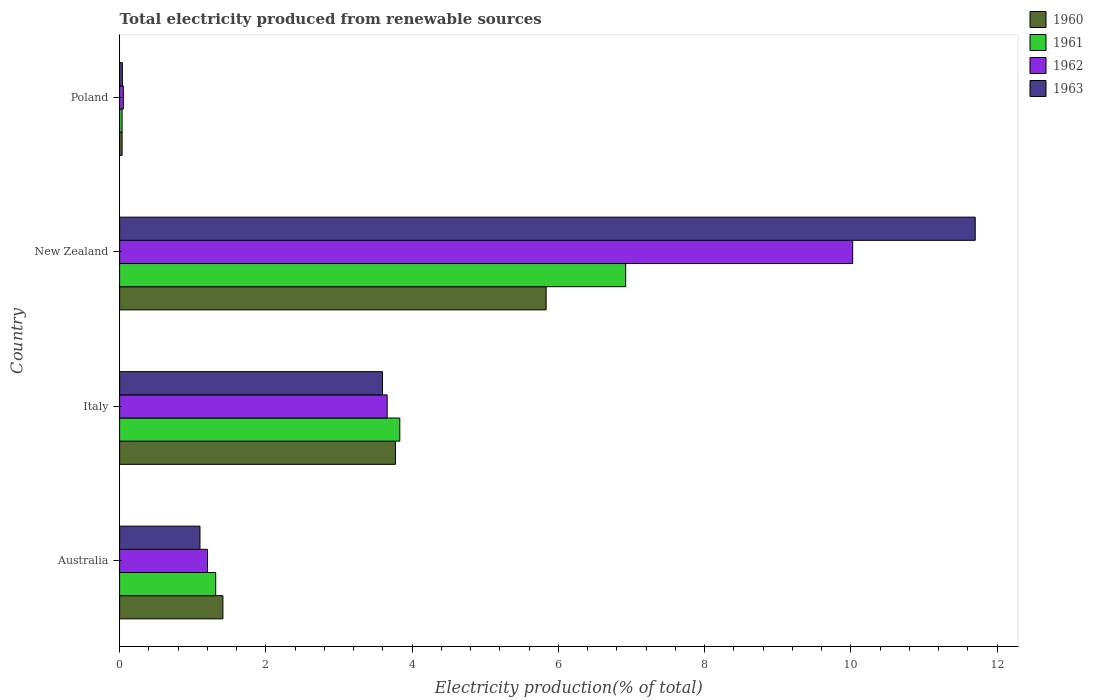How many groups of bars are there?
Provide a succinct answer. 4. How many bars are there on the 3rd tick from the bottom?
Provide a short and direct response. 4. What is the total electricity produced in 1962 in Italy?
Offer a very short reply. 3.66. Across all countries, what is the maximum total electricity produced in 1963?
Your answer should be compact. 11.7. Across all countries, what is the minimum total electricity produced in 1960?
Your answer should be very brief. 0.03. In which country was the total electricity produced in 1962 maximum?
Keep it short and to the point. New Zealand. In which country was the total electricity produced in 1963 minimum?
Make the answer very short. Poland. What is the total total electricity produced in 1962 in the graph?
Offer a terse response. 14.94. What is the difference between the total electricity produced in 1960 in Australia and that in Italy?
Your answer should be very brief. -2.36. What is the difference between the total electricity produced in 1963 in Australia and the total electricity produced in 1962 in New Zealand?
Offer a very short reply. -8.93. What is the average total electricity produced in 1962 per country?
Provide a short and direct response. 3.73. What is the difference between the total electricity produced in 1962 and total electricity produced in 1961 in Italy?
Keep it short and to the point. -0.17. In how many countries, is the total electricity produced in 1962 greater than 6.4 %?
Keep it short and to the point. 1. What is the ratio of the total electricity produced in 1960 in Italy to that in New Zealand?
Your answer should be compact. 0.65. Is the total electricity produced in 1963 in Italy less than that in New Zealand?
Make the answer very short. Yes. Is the difference between the total electricity produced in 1962 in Italy and New Zealand greater than the difference between the total electricity produced in 1961 in Italy and New Zealand?
Ensure brevity in your answer.  No. What is the difference between the highest and the second highest total electricity produced in 1962?
Offer a terse response. 6.37. What is the difference between the highest and the lowest total electricity produced in 1962?
Provide a succinct answer. 9.97. In how many countries, is the total electricity produced in 1962 greater than the average total electricity produced in 1962 taken over all countries?
Keep it short and to the point. 1. Is the sum of the total electricity produced in 1961 in Australia and Poland greater than the maximum total electricity produced in 1960 across all countries?
Your answer should be compact. No. Is it the case that in every country, the sum of the total electricity produced in 1961 and total electricity produced in 1960 is greater than the sum of total electricity produced in 1962 and total electricity produced in 1963?
Provide a succinct answer. No. What does the 4th bar from the bottom in Australia represents?
Offer a terse response. 1963. Is it the case that in every country, the sum of the total electricity produced in 1960 and total electricity produced in 1961 is greater than the total electricity produced in 1963?
Give a very brief answer. Yes. How many bars are there?
Offer a very short reply. 16. Does the graph contain any zero values?
Offer a terse response. No. Does the graph contain grids?
Give a very brief answer. No. Where does the legend appear in the graph?
Give a very brief answer. Top right. How many legend labels are there?
Your answer should be very brief. 4. What is the title of the graph?
Keep it short and to the point. Total electricity produced from renewable sources. What is the label or title of the X-axis?
Your answer should be compact. Electricity production(% of total). What is the label or title of the Y-axis?
Provide a short and direct response. Country. What is the Electricity production(% of total) of 1960 in Australia?
Provide a succinct answer. 1.41. What is the Electricity production(% of total) of 1961 in Australia?
Offer a very short reply. 1.31. What is the Electricity production(% of total) of 1962 in Australia?
Give a very brief answer. 1.2. What is the Electricity production(% of total) in 1963 in Australia?
Your response must be concise. 1.1. What is the Electricity production(% of total) of 1960 in Italy?
Your answer should be very brief. 3.77. What is the Electricity production(% of total) of 1961 in Italy?
Your answer should be compact. 3.83. What is the Electricity production(% of total) in 1962 in Italy?
Give a very brief answer. 3.66. What is the Electricity production(% of total) of 1963 in Italy?
Provide a succinct answer. 3.59. What is the Electricity production(% of total) in 1960 in New Zealand?
Offer a terse response. 5.83. What is the Electricity production(% of total) of 1961 in New Zealand?
Your answer should be very brief. 6.92. What is the Electricity production(% of total) of 1962 in New Zealand?
Provide a succinct answer. 10.02. What is the Electricity production(% of total) of 1963 in New Zealand?
Your response must be concise. 11.7. What is the Electricity production(% of total) in 1960 in Poland?
Give a very brief answer. 0.03. What is the Electricity production(% of total) of 1961 in Poland?
Your answer should be compact. 0.03. What is the Electricity production(% of total) in 1962 in Poland?
Provide a short and direct response. 0.05. What is the Electricity production(% of total) in 1963 in Poland?
Offer a very short reply. 0.04. Across all countries, what is the maximum Electricity production(% of total) of 1960?
Provide a succinct answer. 5.83. Across all countries, what is the maximum Electricity production(% of total) in 1961?
Ensure brevity in your answer.  6.92. Across all countries, what is the maximum Electricity production(% of total) in 1962?
Your answer should be compact. 10.02. Across all countries, what is the maximum Electricity production(% of total) in 1963?
Provide a succinct answer. 11.7. Across all countries, what is the minimum Electricity production(% of total) of 1960?
Offer a terse response. 0.03. Across all countries, what is the minimum Electricity production(% of total) of 1961?
Give a very brief answer. 0.03. Across all countries, what is the minimum Electricity production(% of total) in 1962?
Your answer should be compact. 0.05. Across all countries, what is the minimum Electricity production(% of total) of 1963?
Your answer should be very brief. 0.04. What is the total Electricity production(% of total) in 1960 in the graph?
Keep it short and to the point. 11.05. What is the total Electricity production(% of total) of 1961 in the graph?
Provide a succinct answer. 12.1. What is the total Electricity production(% of total) of 1962 in the graph?
Give a very brief answer. 14.94. What is the total Electricity production(% of total) in 1963 in the graph?
Offer a very short reply. 16.43. What is the difference between the Electricity production(% of total) in 1960 in Australia and that in Italy?
Your answer should be very brief. -2.36. What is the difference between the Electricity production(% of total) of 1961 in Australia and that in Italy?
Ensure brevity in your answer.  -2.52. What is the difference between the Electricity production(% of total) in 1962 in Australia and that in Italy?
Provide a succinct answer. -2.46. What is the difference between the Electricity production(% of total) of 1963 in Australia and that in Italy?
Make the answer very short. -2.5. What is the difference between the Electricity production(% of total) of 1960 in Australia and that in New Zealand?
Your answer should be compact. -4.42. What is the difference between the Electricity production(% of total) in 1961 in Australia and that in New Zealand?
Ensure brevity in your answer.  -5.61. What is the difference between the Electricity production(% of total) of 1962 in Australia and that in New Zealand?
Provide a short and direct response. -8.82. What is the difference between the Electricity production(% of total) in 1963 in Australia and that in New Zealand?
Your answer should be compact. -10.6. What is the difference between the Electricity production(% of total) in 1960 in Australia and that in Poland?
Provide a short and direct response. 1.38. What is the difference between the Electricity production(% of total) of 1961 in Australia and that in Poland?
Your answer should be very brief. 1.28. What is the difference between the Electricity production(% of total) of 1962 in Australia and that in Poland?
Ensure brevity in your answer.  1.15. What is the difference between the Electricity production(% of total) in 1963 in Australia and that in Poland?
Provide a succinct answer. 1.06. What is the difference between the Electricity production(% of total) in 1960 in Italy and that in New Zealand?
Your response must be concise. -2.06. What is the difference between the Electricity production(% of total) in 1961 in Italy and that in New Zealand?
Your answer should be very brief. -3.09. What is the difference between the Electricity production(% of total) in 1962 in Italy and that in New Zealand?
Your response must be concise. -6.37. What is the difference between the Electricity production(% of total) in 1963 in Italy and that in New Zealand?
Make the answer very short. -8.11. What is the difference between the Electricity production(% of total) in 1960 in Italy and that in Poland?
Provide a succinct answer. 3.74. What is the difference between the Electricity production(% of total) in 1961 in Italy and that in Poland?
Offer a very short reply. 3.8. What is the difference between the Electricity production(% of total) in 1962 in Italy and that in Poland?
Your answer should be very brief. 3.61. What is the difference between the Electricity production(% of total) of 1963 in Italy and that in Poland?
Ensure brevity in your answer.  3.56. What is the difference between the Electricity production(% of total) in 1960 in New Zealand and that in Poland?
Make the answer very short. 5.8. What is the difference between the Electricity production(% of total) of 1961 in New Zealand and that in Poland?
Make the answer very short. 6.89. What is the difference between the Electricity production(% of total) of 1962 in New Zealand and that in Poland?
Your answer should be very brief. 9.97. What is the difference between the Electricity production(% of total) of 1963 in New Zealand and that in Poland?
Your answer should be compact. 11.66. What is the difference between the Electricity production(% of total) in 1960 in Australia and the Electricity production(% of total) in 1961 in Italy?
Offer a terse response. -2.42. What is the difference between the Electricity production(% of total) in 1960 in Australia and the Electricity production(% of total) in 1962 in Italy?
Keep it short and to the point. -2.25. What is the difference between the Electricity production(% of total) of 1960 in Australia and the Electricity production(% of total) of 1963 in Italy?
Offer a very short reply. -2.18. What is the difference between the Electricity production(% of total) of 1961 in Australia and the Electricity production(% of total) of 1962 in Italy?
Your response must be concise. -2.34. What is the difference between the Electricity production(% of total) of 1961 in Australia and the Electricity production(% of total) of 1963 in Italy?
Keep it short and to the point. -2.28. What is the difference between the Electricity production(% of total) in 1962 in Australia and the Electricity production(% of total) in 1963 in Italy?
Give a very brief answer. -2.39. What is the difference between the Electricity production(% of total) in 1960 in Australia and the Electricity production(% of total) in 1961 in New Zealand?
Your answer should be very brief. -5.51. What is the difference between the Electricity production(% of total) of 1960 in Australia and the Electricity production(% of total) of 1962 in New Zealand?
Offer a terse response. -8.61. What is the difference between the Electricity production(% of total) in 1960 in Australia and the Electricity production(% of total) in 1963 in New Zealand?
Ensure brevity in your answer.  -10.29. What is the difference between the Electricity production(% of total) in 1961 in Australia and the Electricity production(% of total) in 1962 in New Zealand?
Provide a short and direct response. -8.71. What is the difference between the Electricity production(% of total) in 1961 in Australia and the Electricity production(% of total) in 1963 in New Zealand?
Provide a succinct answer. -10.39. What is the difference between the Electricity production(% of total) of 1962 in Australia and the Electricity production(% of total) of 1963 in New Zealand?
Ensure brevity in your answer.  -10.5. What is the difference between the Electricity production(% of total) in 1960 in Australia and the Electricity production(% of total) in 1961 in Poland?
Offer a terse response. 1.38. What is the difference between the Electricity production(% of total) in 1960 in Australia and the Electricity production(% of total) in 1962 in Poland?
Provide a short and direct response. 1.36. What is the difference between the Electricity production(% of total) of 1960 in Australia and the Electricity production(% of total) of 1963 in Poland?
Offer a very short reply. 1.37. What is the difference between the Electricity production(% of total) in 1961 in Australia and the Electricity production(% of total) in 1962 in Poland?
Ensure brevity in your answer.  1.26. What is the difference between the Electricity production(% of total) of 1961 in Australia and the Electricity production(% of total) of 1963 in Poland?
Make the answer very short. 1.28. What is the difference between the Electricity production(% of total) of 1962 in Australia and the Electricity production(% of total) of 1963 in Poland?
Give a very brief answer. 1.16. What is the difference between the Electricity production(% of total) in 1960 in Italy and the Electricity production(% of total) in 1961 in New Zealand?
Offer a very short reply. -3.15. What is the difference between the Electricity production(% of total) in 1960 in Italy and the Electricity production(% of total) in 1962 in New Zealand?
Give a very brief answer. -6.25. What is the difference between the Electricity production(% of total) in 1960 in Italy and the Electricity production(% of total) in 1963 in New Zealand?
Your answer should be compact. -7.93. What is the difference between the Electricity production(% of total) in 1961 in Italy and the Electricity production(% of total) in 1962 in New Zealand?
Keep it short and to the point. -6.19. What is the difference between the Electricity production(% of total) in 1961 in Italy and the Electricity production(% of total) in 1963 in New Zealand?
Your answer should be compact. -7.87. What is the difference between the Electricity production(% of total) in 1962 in Italy and the Electricity production(% of total) in 1963 in New Zealand?
Provide a succinct answer. -8.04. What is the difference between the Electricity production(% of total) of 1960 in Italy and the Electricity production(% of total) of 1961 in Poland?
Offer a terse response. 3.74. What is the difference between the Electricity production(% of total) of 1960 in Italy and the Electricity production(% of total) of 1962 in Poland?
Provide a succinct answer. 3.72. What is the difference between the Electricity production(% of total) of 1960 in Italy and the Electricity production(% of total) of 1963 in Poland?
Keep it short and to the point. 3.73. What is the difference between the Electricity production(% of total) of 1961 in Italy and the Electricity production(% of total) of 1962 in Poland?
Offer a very short reply. 3.78. What is the difference between the Electricity production(% of total) of 1961 in Italy and the Electricity production(% of total) of 1963 in Poland?
Provide a succinct answer. 3.79. What is the difference between the Electricity production(% of total) in 1962 in Italy and the Electricity production(% of total) in 1963 in Poland?
Give a very brief answer. 3.62. What is the difference between the Electricity production(% of total) of 1960 in New Zealand and the Electricity production(% of total) of 1961 in Poland?
Your answer should be very brief. 5.8. What is the difference between the Electricity production(% of total) in 1960 in New Zealand and the Electricity production(% of total) in 1962 in Poland?
Offer a very short reply. 5.78. What is the difference between the Electricity production(% of total) in 1960 in New Zealand and the Electricity production(% of total) in 1963 in Poland?
Offer a very short reply. 5.79. What is the difference between the Electricity production(% of total) in 1961 in New Zealand and the Electricity production(% of total) in 1962 in Poland?
Offer a very short reply. 6.87. What is the difference between the Electricity production(% of total) in 1961 in New Zealand and the Electricity production(% of total) in 1963 in Poland?
Provide a succinct answer. 6.88. What is the difference between the Electricity production(% of total) of 1962 in New Zealand and the Electricity production(% of total) of 1963 in Poland?
Offer a terse response. 9.99. What is the average Electricity production(% of total) of 1960 per country?
Your answer should be compact. 2.76. What is the average Electricity production(% of total) of 1961 per country?
Your answer should be very brief. 3.02. What is the average Electricity production(% of total) of 1962 per country?
Make the answer very short. 3.73. What is the average Electricity production(% of total) in 1963 per country?
Ensure brevity in your answer.  4.11. What is the difference between the Electricity production(% of total) of 1960 and Electricity production(% of total) of 1961 in Australia?
Give a very brief answer. 0.1. What is the difference between the Electricity production(% of total) in 1960 and Electricity production(% of total) in 1962 in Australia?
Keep it short and to the point. 0.21. What is the difference between the Electricity production(% of total) of 1960 and Electricity production(% of total) of 1963 in Australia?
Provide a short and direct response. 0.31. What is the difference between the Electricity production(% of total) in 1961 and Electricity production(% of total) in 1962 in Australia?
Offer a very short reply. 0.11. What is the difference between the Electricity production(% of total) in 1961 and Electricity production(% of total) in 1963 in Australia?
Your response must be concise. 0.21. What is the difference between the Electricity production(% of total) of 1962 and Electricity production(% of total) of 1963 in Australia?
Your answer should be very brief. 0.1. What is the difference between the Electricity production(% of total) in 1960 and Electricity production(% of total) in 1961 in Italy?
Ensure brevity in your answer.  -0.06. What is the difference between the Electricity production(% of total) in 1960 and Electricity production(% of total) in 1962 in Italy?
Make the answer very short. 0.11. What is the difference between the Electricity production(% of total) in 1960 and Electricity production(% of total) in 1963 in Italy?
Give a very brief answer. 0.18. What is the difference between the Electricity production(% of total) of 1961 and Electricity production(% of total) of 1962 in Italy?
Your response must be concise. 0.17. What is the difference between the Electricity production(% of total) of 1961 and Electricity production(% of total) of 1963 in Italy?
Keep it short and to the point. 0.24. What is the difference between the Electricity production(% of total) in 1962 and Electricity production(% of total) in 1963 in Italy?
Provide a short and direct response. 0.06. What is the difference between the Electricity production(% of total) in 1960 and Electricity production(% of total) in 1961 in New Zealand?
Your answer should be very brief. -1.09. What is the difference between the Electricity production(% of total) in 1960 and Electricity production(% of total) in 1962 in New Zealand?
Offer a very short reply. -4.19. What is the difference between the Electricity production(% of total) of 1960 and Electricity production(% of total) of 1963 in New Zealand?
Provide a short and direct response. -5.87. What is the difference between the Electricity production(% of total) in 1961 and Electricity production(% of total) in 1962 in New Zealand?
Your response must be concise. -3.1. What is the difference between the Electricity production(% of total) in 1961 and Electricity production(% of total) in 1963 in New Zealand?
Ensure brevity in your answer.  -4.78. What is the difference between the Electricity production(% of total) of 1962 and Electricity production(% of total) of 1963 in New Zealand?
Ensure brevity in your answer.  -1.68. What is the difference between the Electricity production(% of total) of 1960 and Electricity production(% of total) of 1961 in Poland?
Your answer should be very brief. 0. What is the difference between the Electricity production(% of total) in 1960 and Electricity production(% of total) in 1962 in Poland?
Make the answer very short. -0.02. What is the difference between the Electricity production(% of total) of 1960 and Electricity production(% of total) of 1963 in Poland?
Keep it short and to the point. -0. What is the difference between the Electricity production(% of total) of 1961 and Electricity production(% of total) of 1962 in Poland?
Offer a terse response. -0.02. What is the difference between the Electricity production(% of total) in 1961 and Electricity production(% of total) in 1963 in Poland?
Offer a terse response. -0. What is the difference between the Electricity production(% of total) of 1962 and Electricity production(% of total) of 1963 in Poland?
Provide a short and direct response. 0.01. What is the ratio of the Electricity production(% of total) in 1960 in Australia to that in Italy?
Provide a succinct answer. 0.37. What is the ratio of the Electricity production(% of total) in 1961 in Australia to that in Italy?
Your answer should be very brief. 0.34. What is the ratio of the Electricity production(% of total) of 1962 in Australia to that in Italy?
Keep it short and to the point. 0.33. What is the ratio of the Electricity production(% of total) of 1963 in Australia to that in Italy?
Provide a succinct answer. 0.31. What is the ratio of the Electricity production(% of total) in 1960 in Australia to that in New Zealand?
Your response must be concise. 0.24. What is the ratio of the Electricity production(% of total) of 1961 in Australia to that in New Zealand?
Offer a terse response. 0.19. What is the ratio of the Electricity production(% of total) in 1962 in Australia to that in New Zealand?
Offer a very short reply. 0.12. What is the ratio of the Electricity production(% of total) of 1963 in Australia to that in New Zealand?
Your answer should be compact. 0.09. What is the ratio of the Electricity production(% of total) in 1960 in Australia to that in Poland?
Give a very brief answer. 41.37. What is the ratio of the Electricity production(% of total) of 1961 in Australia to that in Poland?
Offer a very short reply. 38.51. What is the ratio of the Electricity production(% of total) of 1962 in Australia to that in Poland?
Offer a very short reply. 23.61. What is the ratio of the Electricity production(% of total) of 1963 in Australia to that in Poland?
Your answer should be compact. 29. What is the ratio of the Electricity production(% of total) of 1960 in Italy to that in New Zealand?
Make the answer very short. 0.65. What is the ratio of the Electricity production(% of total) in 1961 in Italy to that in New Zealand?
Ensure brevity in your answer.  0.55. What is the ratio of the Electricity production(% of total) of 1962 in Italy to that in New Zealand?
Keep it short and to the point. 0.36. What is the ratio of the Electricity production(% of total) in 1963 in Italy to that in New Zealand?
Keep it short and to the point. 0.31. What is the ratio of the Electricity production(% of total) in 1960 in Italy to that in Poland?
Keep it short and to the point. 110.45. What is the ratio of the Electricity production(% of total) in 1961 in Italy to that in Poland?
Offer a very short reply. 112.3. What is the ratio of the Electricity production(% of total) of 1962 in Italy to that in Poland?
Offer a terse response. 71.88. What is the ratio of the Electricity production(% of total) of 1963 in Italy to that in Poland?
Provide a succinct answer. 94.84. What is the ratio of the Electricity production(% of total) in 1960 in New Zealand to that in Poland?
Provide a succinct answer. 170.79. What is the ratio of the Electricity production(% of total) of 1961 in New Zealand to that in Poland?
Offer a terse response. 202.83. What is the ratio of the Electricity production(% of total) of 1962 in New Zealand to that in Poland?
Keep it short and to the point. 196.95. What is the ratio of the Electricity production(% of total) in 1963 in New Zealand to that in Poland?
Your answer should be compact. 308.73. What is the difference between the highest and the second highest Electricity production(% of total) in 1960?
Give a very brief answer. 2.06. What is the difference between the highest and the second highest Electricity production(% of total) in 1961?
Your response must be concise. 3.09. What is the difference between the highest and the second highest Electricity production(% of total) of 1962?
Offer a terse response. 6.37. What is the difference between the highest and the second highest Electricity production(% of total) of 1963?
Offer a very short reply. 8.11. What is the difference between the highest and the lowest Electricity production(% of total) in 1960?
Your answer should be compact. 5.8. What is the difference between the highest and the lowest Electricity production(% of total) in 1961?
Offer a very short reply. 6.89. What is the difference between the highest and the lowest Electricity production(% of total) of 1962?
Your response must be concise. 9.97. What is the difference between the highest and the lowest Electricity production(% of total) of 1963?
Provide a short and direct response. 11.66. 